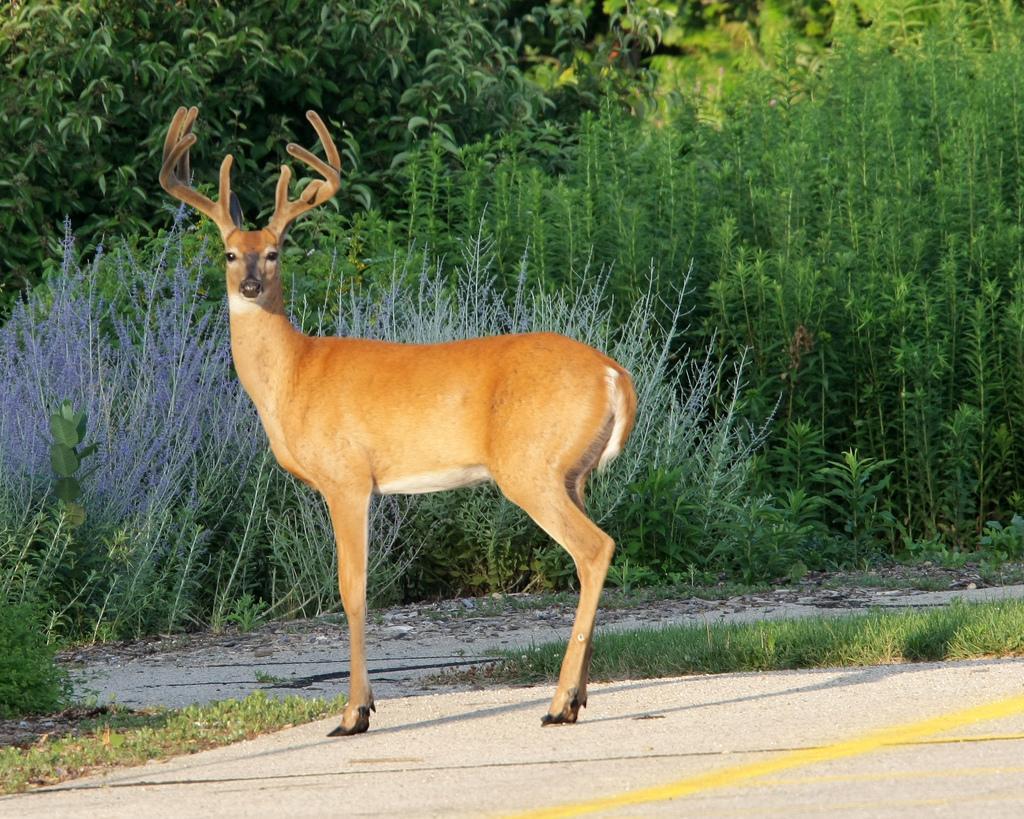Describe this image in one or two sentences. In this image we can see deer. In the back there are plants and trees. And there's grass on the ground. 